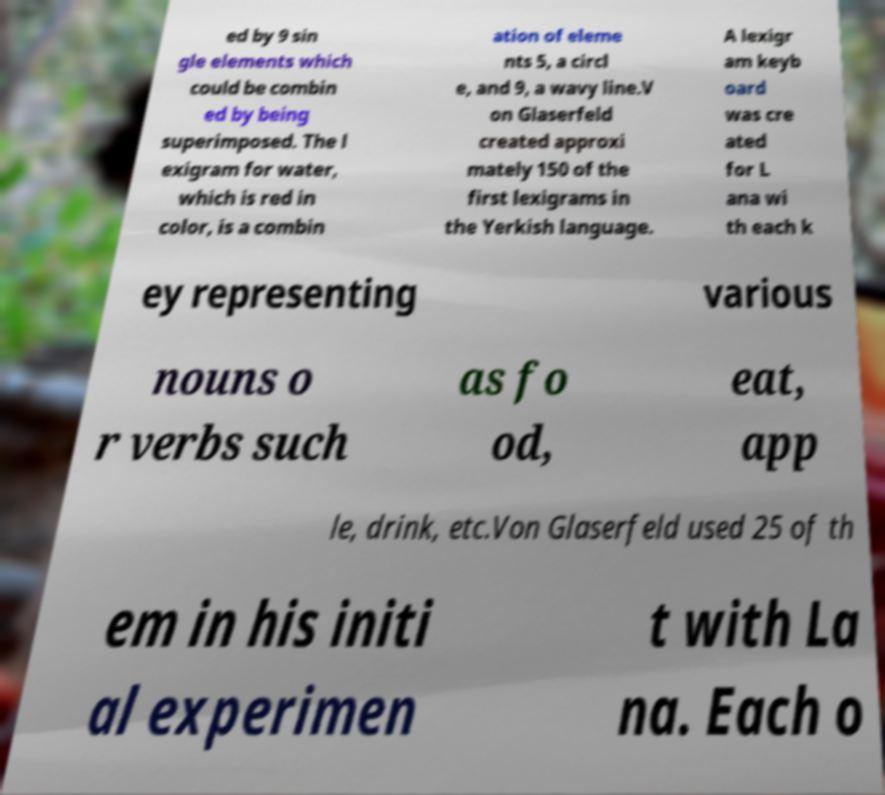Please read and relay the text visible in this image. What does it say? ed by 9 sin gle elements which could be combin ed by being superimposed. The l exigram for water, which is red in color, is a combin ation of eleme nts 5, a circl e, and 9, a wavy line.V on Glaserfeld created approxi mately 150 of the first lexigrams in the Yerkish language. A lexigr am keyb oard was cre ated for L ana wi th each k ey representing various nouns o r verbs such as fo od, eat, app le, drink, etc.Von Glaserfeld used 25 of th em in his initi al experimen t with La na. Each o 